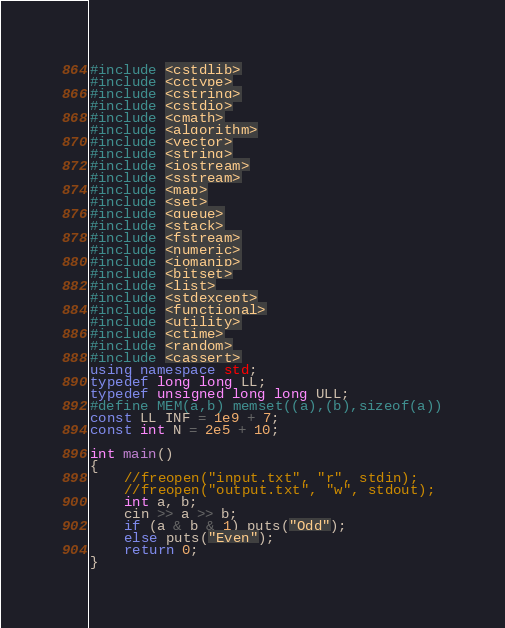<code> <loc_0><loc_0><loc_500><loc_500><_C++_>#include <cstdlib>
#include <cctype>
#include <cstring>
#include <cstdio>
#include <cmath>
#include <algorithm>
#include <vector>
#include <string>
#include <iostream>
#include <sstream>
#include <map>
#include <set>
#include <queue>
#include <stack>
#include <fstream>
#include <numeric>
#include <iomanip>
#include <bitset>
#include <list>
#include <stdexcept>
#include <functional>
#include <utility>
#include <ctime>
#include <random>
#include <cassert>
using namespace std;
typedef long long LL;
typedef unsigned long long ULL;
#define MEM(a,b) memset((a),(b),sizeof(a))
const LL INF = 1e9 + 7;
const int N = 2e5 + 10;

int main()
{
	//freopen("input.txt", "r", stdin);
	//freopen("output.txt", "w", stdout);
	int a, b;
	cin >> a >> b;
	if (a & b & 1) puts("Odd");
	else puts("Even");
	return 0;
}
</code> 